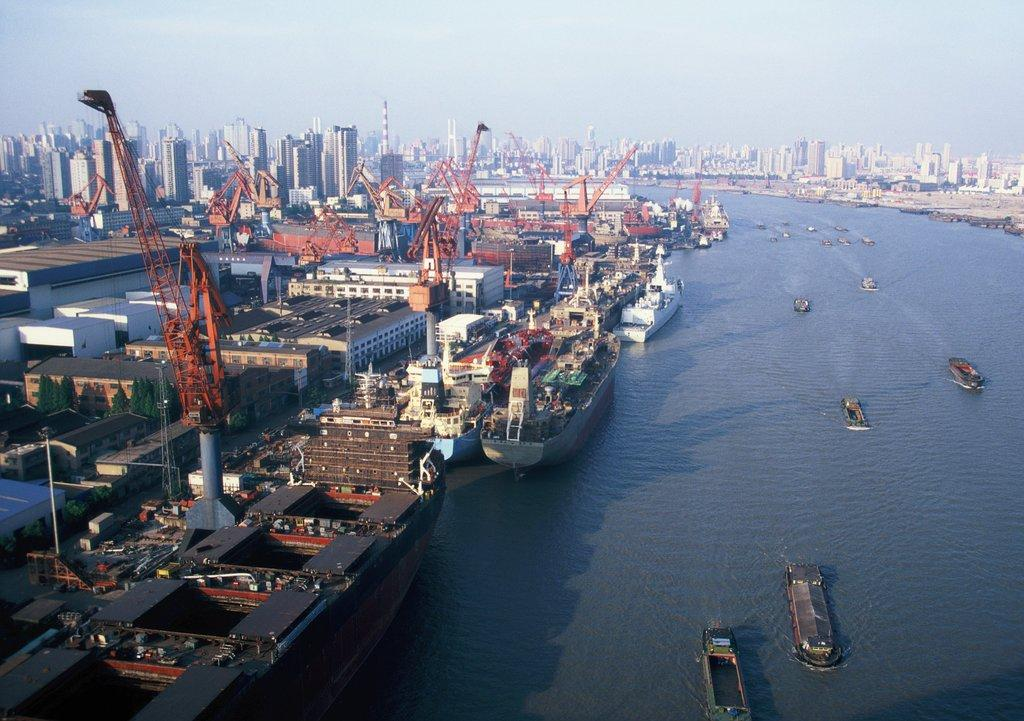What is on the water in the image? There are boats on the water in the image. What type of structures can be seen in the image? There are buildings in the image. What equipment is present in the image? There are cranes in the image. What type of vegetation is visible in the image? There are trees in the image. What is visible in the background of the image? The sky is visible in the background of the image. Where is the camp located in the image? There is no camp present in the image. How many planes are flying in the sky in the image? There are no planes visible in the image; only boats, buildings, cranes, trees, and the sky are present. 